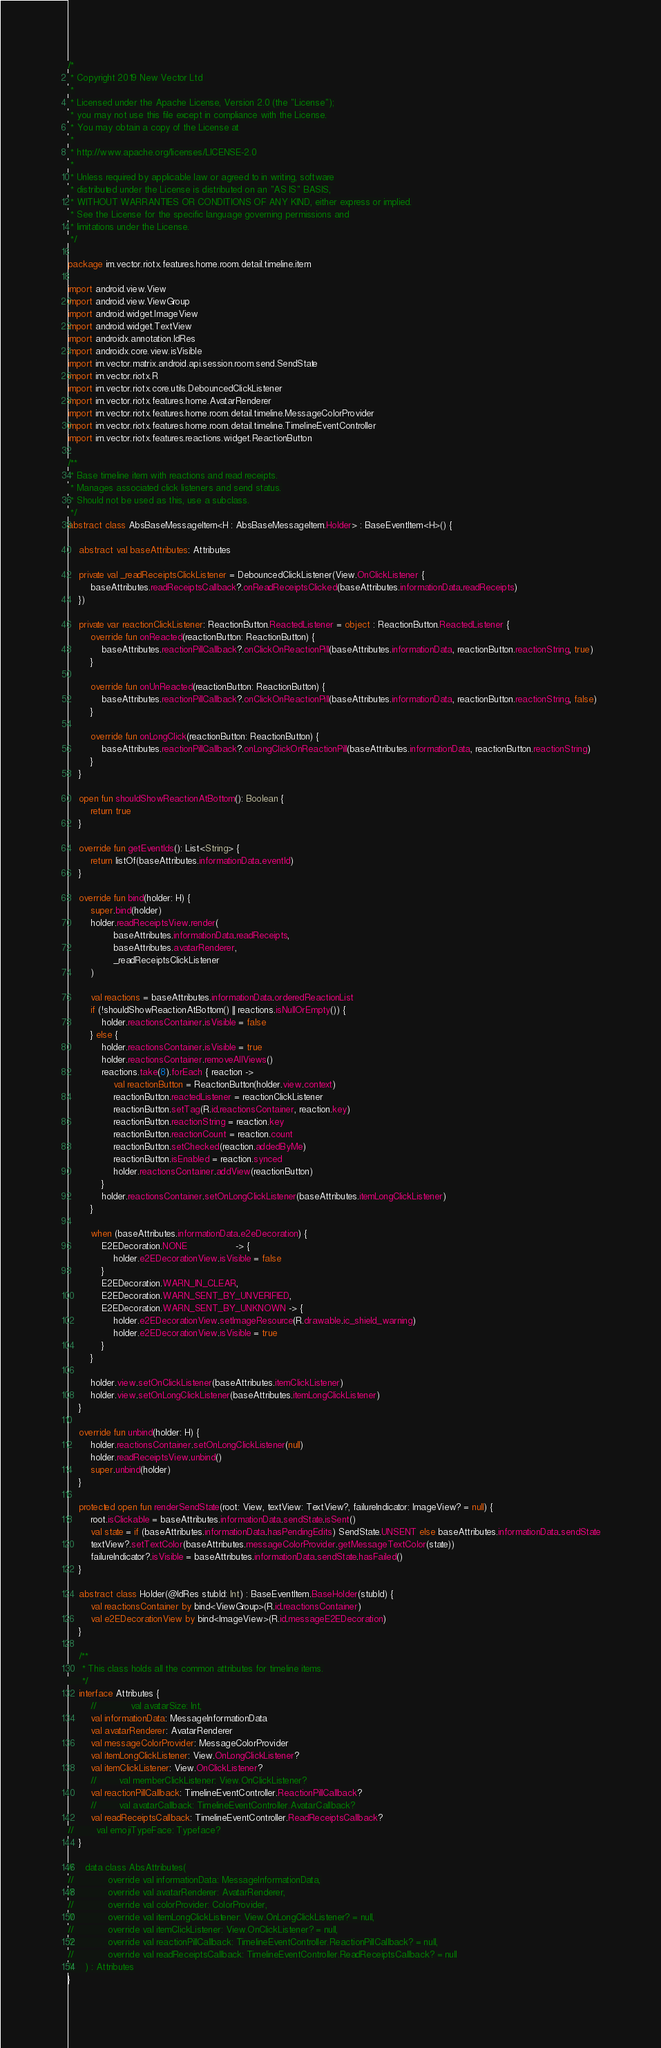<code> <loc_0><loc_0><loc_500><loc_500><_Kotlin_>/*
 * Copyright 2019 New Vector Ltd
 *
 * Licensed under the Apache License, Version 2.0 (the "License");
 * you may not use this file except in compliance with the License.
 * You may obtain a copy of the License at
 *
 * http://www.apache.org/licenses/LICENSE-2.0
 *
 * Unless required by applicable law or agreed to in writing, software
 * distributed under the License is distributed on an "AS IS" BASIS,
 * WITHOUT WARRANTIES OR CONDITIONS OF ANY KIND, either express or implied.
 * See the License for the specific language governing permissions and
 * limitations under the License.
 */

package im.vector.riotx.features.home.room.detail.timeline.item

import android.view.View
import android.view.ViewGroup
import android.widget.ImageView
import android.widget.TextView
import androidx.annotation.IdRes
import androidx.core.view.isVisible
import im.vector.matrix.android.api.session.room.send.SendState
import im.vector.riotx.R
import im.vector.riotx.core.utils.DebouncedClickListener
import im.vector.riotx.features.home.AvatarRenderer
import im.vector.riotx.features.home.room.detail.timeline.MessageColorProvider
import im.vector.riotx.features.home.room.detail.timeline.TimelineEventController
import im.vector.riotx.features.reactions.widget.ReactionButton

/**
 * Base timeline item with reactions and read receipts.
 * Manages associated click listeners and send status.
 * Should not be used as this, use a subclass.
 */
abstract class AbsBaseMessageItem<H : AbsBaseMessageItem.Holder> : BaseEventItem<H>() {

    abstract val baseAttributes: Attributes

    private val _readReceiptsClickListener = DebouncedClickListener(View.OnClickListener {
        baseAttributes.readReceiptsCallback?.onReadReceiptsClicked(baseAttributes.informationData.readReceipts)
    })

    private var reactionClickListener: ReactionButton.ReactedListener = object : ReactionButton.ReactedListener {
        override fun onReacted(reactionButton: ReactionButton) {
            baseAttributes.reactionPillCallback?.onClickOnReactionPill(baseAttributes.informationData, reactionButton.reactionString, true)
        }

        override fun onUnReacted(reactionButton: ReactionButton) {
            baseAttributes.reactionPillCallback?.onClickOnReactionPill(baseAttributes.informationData, reactionButton.reactionString, false)
        }

        override fun onLongClick(reactionButton: ReactionButton) {
            baseAttributes.reactionPillCallback?.onLongClickOnReactionPill(baseAttributes.informationData, reactionButton.reactionString)
        }
    }

    open fun shouldShowReactionAtBottom(): Boolean {
        return true
    }

    override fun getEventIds(): List<String> {
        return listOf(baseAttributes.informationData.eventId)
    }

    override fun bind(holder: H) {
        super.bind(holder)
        holder.readReceiptsView.render(
                baseAttributes.informationData.readReceipts,
                baseAttributes.avatarRenderer,
                _readReceiptsClickListener
        )

        val reactions = baseAttributes.informationData.orderedReactionList
        if (!shouldShowReactionAtBottom() || reactions.isNullOrEmpty()) {
            holder.reactionsContainer.isVisible = false
        } else {
            holder.reactionsContainer.isVisible = true
            holder.reactionsContainer.removeAllViews()
            reactions.take(8).forEach { reaction ->
                val reactionButton = ReactionButton(holder.view.context)
                reactionButton.reactedListener = reactionClickListener
                reactionButton.setTag(R.id.reactionsContainer, reaction.key)
                reactionButton.reactionString = reaction.key
                reactionButton.reactionCount = reaction.count
                reactionButton.setChecked(reaction.addedByMe)
                reactionButton.isEnabled = reaction.synced
                holder.reactionsContainer.addView(reactionButton)
            }
            holder.reactionsContainer.setOnLongClickListener(baseAttributes.itemLongClickListener)
        }

        when (baseAttributes.informationData.e2eDecoration) {
            E2EDecoration.NONE                 -> {
                holder.e2EDecorationView.isVisible = false
            }
            E2EDecoration.WARN_IN_CLEAR,
            E2EDecoration.WARN_SENT_BY_UNVERIFIED,
            E2EDecoration.WARN_SENT_BY_UNKNOWN -> {
                holder.e2EDecorationView.setImageResource(R.drawable.ic_shield_warning)
                holder.e2EDecorationView.isVisible = true
            }
        }

        holder.view.setOnClickListener(baseAttributes.itemClickListener)
        holder.view.setOnLongClickListener(baseAttributes.itemLongClickListener)
    }

    override fun unbind(holder: H) {
        holder.reactionsContainer.setOnLongClickListener(null)
        holder.readReceiptsView.unbind()
        super.unbind(holder)
    }

    protected open fun renderSendState(root: View, textView: TextView?, failureIndicator: ImageView? = null) {
        root.isClickable = baseAttributes.informationData.sendState.isSent()
        val state = if (baseAttributes.informationData.hasPendingEdits) SendState.UNSENT else baseAttributes.informationData.sendState
        textView?.setTextColor(baseAttributes.messageColorProvider.getMessageTextColor(state))
        failureIndicator?.isVisible = baseAttributes.informationData.sendState.hasFailed()
    }

    abstract class Holder(@IdRes stubId: Int) : BaseEventItem.BaseHolder(stubId) {
        val reactionsContainer by bind<ViewGroup>(R.id.reactionsContainer)
        val e2EDecorationView by bind<ImageView>(R.id.messageE2EDecoration)
    }

    /**
     * This class holds all the common attributes for timeline items.
     */
    interface Attributes {
        //            val avatarSize: Int,
        val informationData: MessageInformationData
        val avatarRenderer: AvatarRenderer
        val messageColorProvider: MessageColorProvider
        val itemLongClickListener: View.OnLongClickListener?
        val itemClickListener: View.OnClickListener?
        //        val memberClickListener: View.OnClickListener?
        val reactionPillCallback: TimelineEventController.ReactionPillCallback?
        //        val avatarCallback: TimelineEventController.AvatarCallback?
        val readReceiptsCallback: TimelineEventController.ReadReceiptsCallback?
//        val emojiTypeFace: Typeface?
    }

//    data class AbsAttributes(
//            override val informationData: MessageInformationData,
//            override val avatarRenderer: AvatarRenderer,
//            override val colorProvider: ColorProvider,
//            override val itemLongClickListener: View.OnLongClickListener? = null,
//            override val itemClickListener: View.OnClickListener? = null,
//            override val reactionPillCallback: TimelineEventController.ReactionPillCallback? = null,
//            override val readReceiptsCallback: TimelineEventController.ReadReceiptsCallback? = null
//    ) : Attributes
}
</code> 